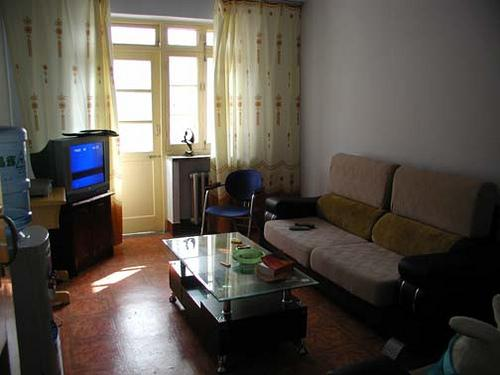Which objects in the image could be used for entertainment purposes? Television on a small table and remote controls on a couch. Identify the type and color of the door in the image for the visual entailment task. A beige wooden and glass door. Which object in the image could be related to an office environment? Blue water bottle on a water cooler. Answer the following question: What color is the small chair in the image, and what material does it appear to be made from? The small chair is blue and appears to be made of plastic and metal. For the product advertisement task, describe an item that could be promoted in a furniture store. A blue chair with silver arms, perfect for adding a touch of style and comfort to any living or office space. Identify the objects found on the coffee table in this image. Green bowl, glass top, and big book. 